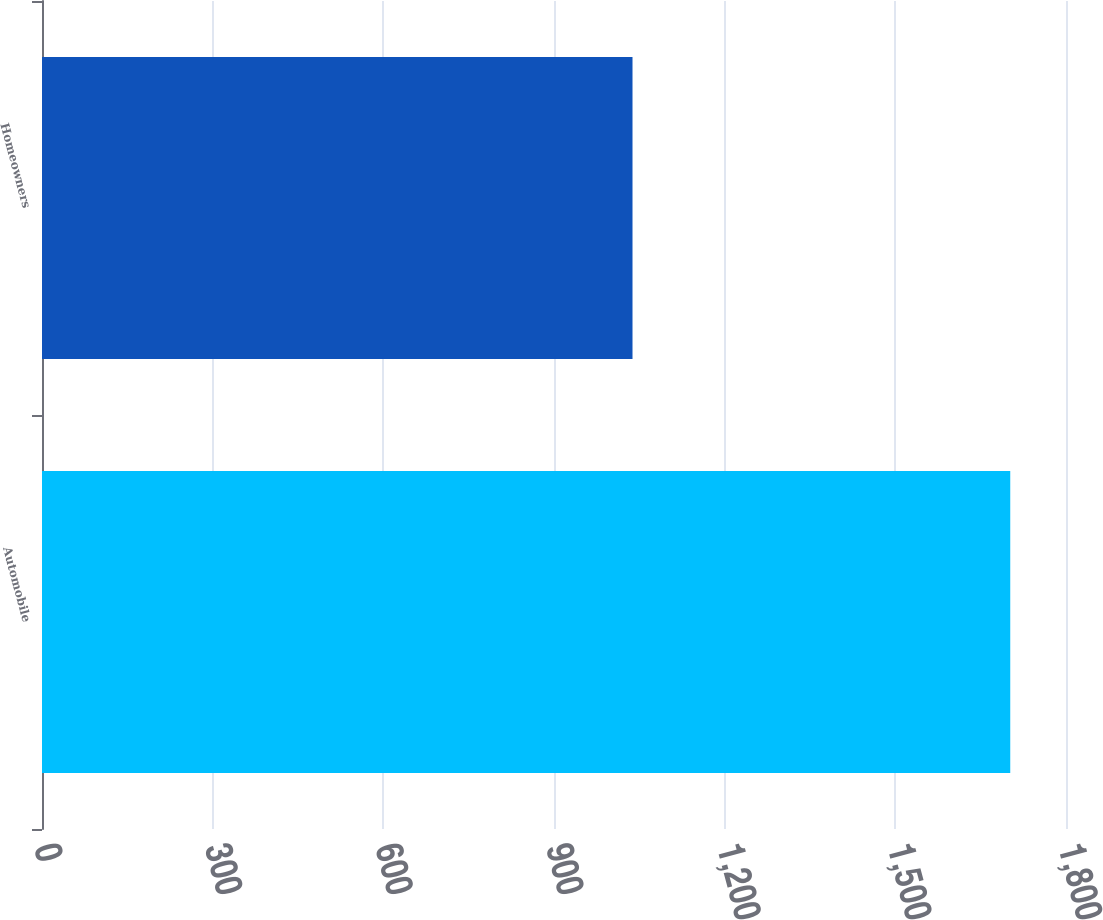<chart> <loc_0><loc_0><loc_500><loc_500><bar_chart><fcel>Automobile<fcel>Homeowners<nl><fcel>1702<fcel>1038<nl></chart> 